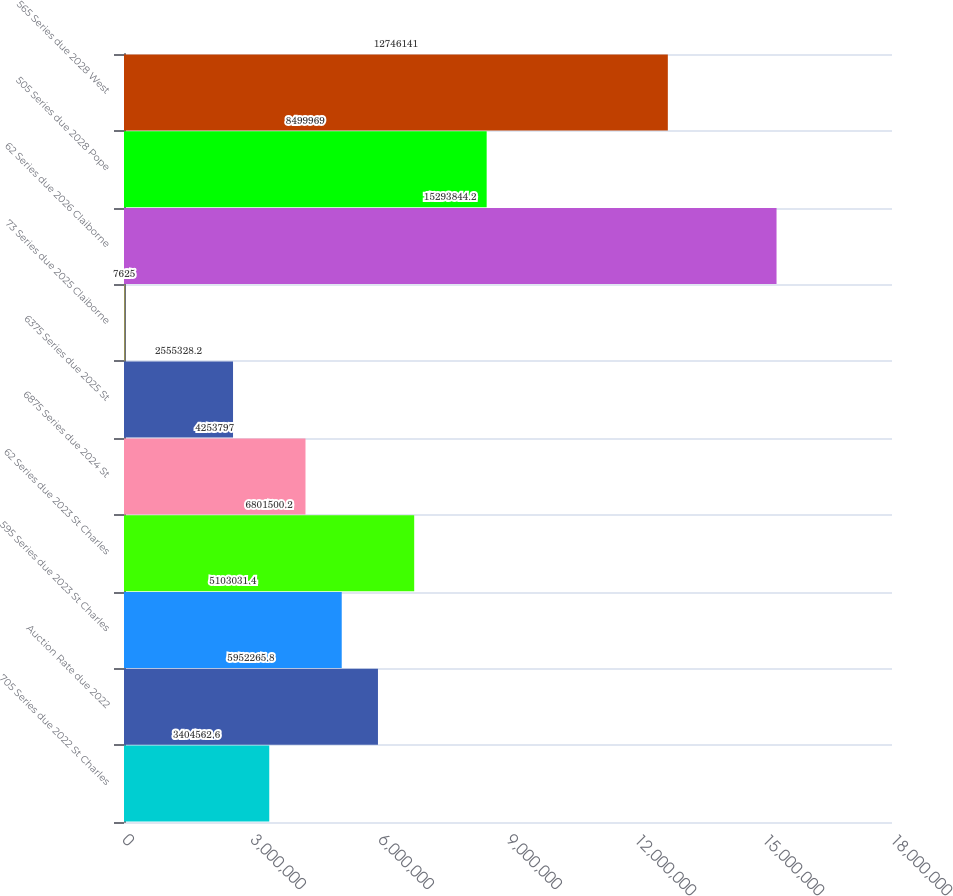Convert chart. <chart><loc_0><loc_0><loc_500><loc_500><bar_chart><fcel>705 Series due 2022 St Charles<fcel>Auction Rate due 2022<fcel>595 Series due 2023 St Charles<fcel>62 Series due 2023 St Charles<fcel>6875 Series due 2024 St<fcel>6375 Series due 2025 St<fcel>73 Series due 2025 Claiborne<fcel>62 Series due 2026 Claiborne<fcel>505 Series due 2028 Pope<fcel>565 Series due 2028 West<nl><fcel>3.40456e+06<fcel>5.95227e+06<fcel>5.10303e+06<fcel>6.8015e+06<fcel>4.2538e+06<fcel>2.55533e+06<fcel>7625<fcel>1.52938e+07<fcel>8.49997e+06<fcel>1.27461e+07<nl></chart> 